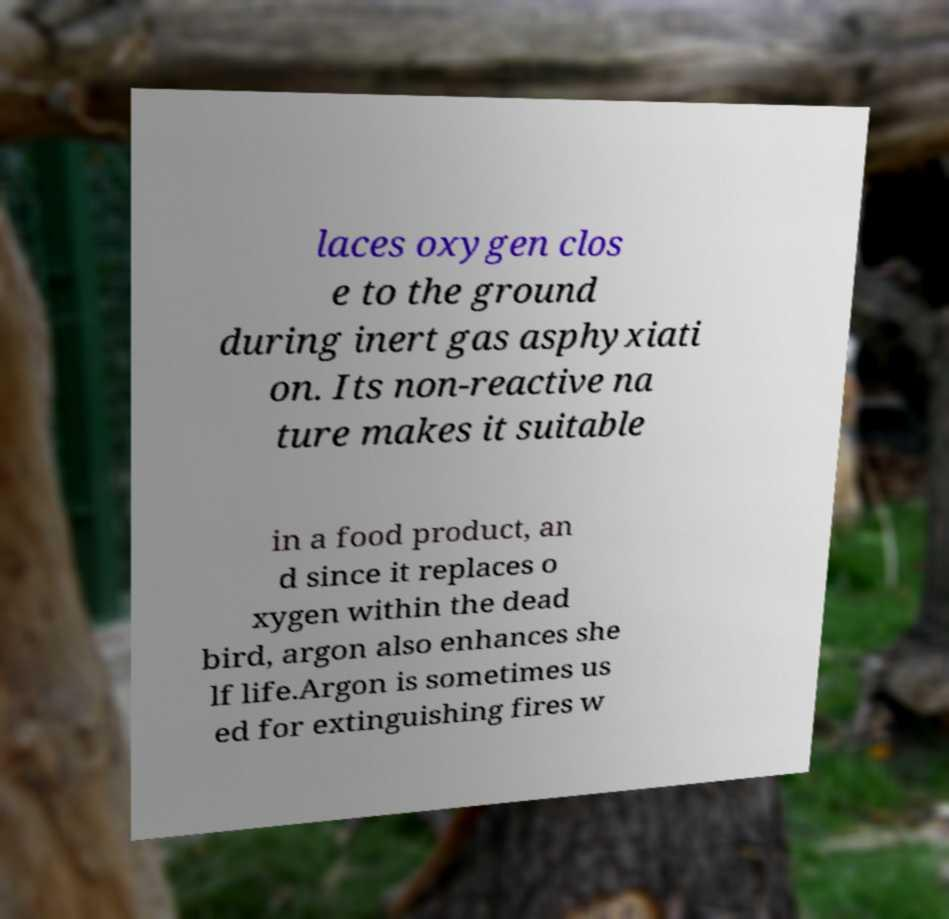What messages or text are displayed in this image? I need them in a readable, typed format. laces oxygen clos e to the ground during inert gas asphyxiati on. Its non-reactive na ture makes it suitable in a food product, an d since it replaces o xygen within the dead bird, argon also enhances she lf life.Argon is sometimes us ed for extinguishing fires w 